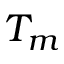<formula> <loc_0><loc_0><loc_500><loc_500>T _ { m }</formula> 